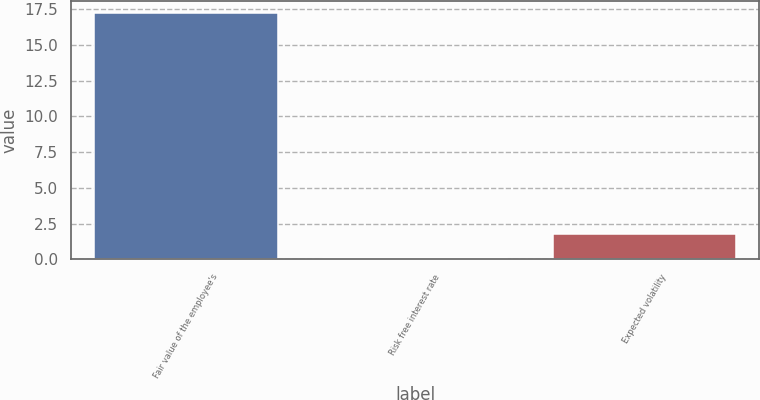Convert chart to OTSL. <chart><loc_0><loc_0><loc_500><loc_500><bar_chart><fcel>Fair value of the employee's<fcel>Risk free interest rate<fcel>Expected volatility<nl><fcel>17.22<fcel>0.1<fcel>1.81<nl></chart> 